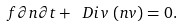<formula> <loc_0><loc_0><loc_500><loc_500>\ f { \partial n } { \partial t } + \ D i v \, \left ( n v \right ) = 0 .</formula> 